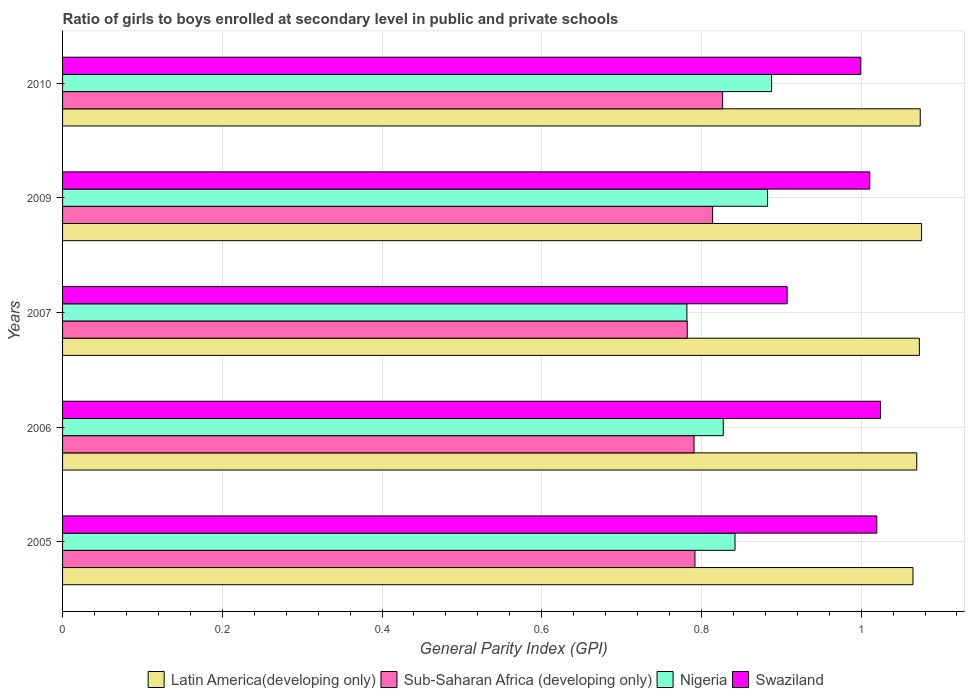How many different coloured bars are there?
Give a very brief answer. 4. How many groups of bars are there?
Offer a terse response. 5. Are the number of bars per tick equal to the number of legend labels?
Provide a short and direct response. Yes. Are the number of bars on each tick of the Y-axis equal?
Make the answer very short. Yes. How many bars are there on the 3rd tick from the bottom?
Provide a short and direct response. 4. What is the general parity index in Swaziland in 2006?
Your answer should be compact. 1.02. Across all years, what is the maximum general parity index in Latin America(developing only)?
Keep it short and to the point. 1.08. Across all years, what is the minimum general parity index in Nigeria?
Provide a succinct answer. 0.78. In which year was the general parity index in Latin America(developing only) minimum?
Ensure brevity in your answer.  2005. What is the total general parity index in Nigeria in the graph?
Offer a terse response. 4.22. What is the difference between the general parity index in Nigeria in 2009 and that in 2010?
Your answer should be very brief. -0. What is the difference between the general parity index in Sub-Saharan Africa (developing only) in 2010 and the general parity index in Latin America(developing only) in 2007?
Your answer should be compact. -0.25. What is the average general parity index in Latin America(developing only) per year?
Your answer should be very brief. 1.07. In the year 2009, what is the difference between the general parity index in Swaziland and general parity index in Latin America(developing only)?
Offer a very short reply. -0.06. In how many years, is the general parity index in Sub-Saharan Africa (developing only) greater than 1 ?
Offer a very short reply. 0. What is the ratio of the general parity index in Sub-Saharan Africa (developing only) in 2005 to that in 2007?
Ensure brevity in your answer.  1.01. Is the general parity index in Sub-Saharan Africa (developing only) in 2005 less than that in 2010?
Give a very brief answer. Yes. Is the difference between the general parity index in Swaziland in 2006 and 2007 greater than the difference between the general parity index in Latin America(developing only) in 2006 and 2007?
Provide a short and direct response. Yes. What is the difference between the highest and the second highest general parity index in Nigeria?
Your answer should be very brief. 0. What is the difference between the highest and the lowest general parity index in Nigeria?
Your answer should be compact. 0.11. Is the sum of the general parity index in Sub-Saharan Africa (developing only) in 2007 and 2009 greater than the maximum general parity index in Nigeria across all years?
Your answer should be compact. Yes. What does the 3rd bar from the top in 2007 represents?
Your response must be concise. Sub-Saharan Africa (developing only). What does the 3rd bar from the bottom in 2006 represents?
Your response must be concise. Nigeria. Is it the case that in every year, the sum of the general parity index in Latin America(developing only) and general parity index in Sub-Saharan Africa (developing only) is greater than the general parity index in Swaziland?
Offer a very short reply. Yes. How many bars are there?
Make the answer very short. 20. Are all the bars in the graph horizontal?
Provide a succinct answer. Yes. Where does the legend appear in the graph?
Offer a very short reply. Bottom center. How many legend labels are there?
Keep it short and to the point. 4. What is the title of the graph?
Provide a succinct answer. Ratio of girls to boys enrolled at secondary level in public and private schools. What is the label or title of the X-axis?
Provide a succinct answer. General Parity Index (GPI). What is the General Parity Index (GPI) in Latin America(developing only) in 2005?
Provide a short and direct response. 1.06. What is the General Parity Index (GPI) of Sub-Saharan Africa (developing only) in 2005?
Offer a very short reply. 0.79. What is the General Parity Index (GPI) of Nigeria in 2005?
Provide a succinct answer. 0.84. What is the General Parity Index (GPI) in Swaziland in 2005?
Your answer should be compact. 1.02. What is the General Parity Index (GPI) of Latin America(developing only) in 2006?
Offer a terse response. 1.07. What is the General Parity Index (GPI) of Sub-Saharan Africa (developing only) in 2006?
Keep it short and to the point. 0.79. What is the General Parity Index (GPI) in Nigeria in 2006?
Your answer should be compact. 0.83. What is the General Parity Index (GPI) in Swaziland in 2006?
Offer a terse response. 1.02. What is the General Parity Index (GPI) of Latin America(developing only) in 2007?
Your answer should be compact. 1.07. What is the General Parity Index (GPI) in Sub-Saharan Africa (developing only) in 2007?
Provide a succinct answer. 0.78. What is the General Parity Index (GPI) in Nigeria in 2007?
Your answer should be very brief. 0.78. What is the General Parity Index (GPI) of Swaziland in 2007?
Make the answer very short. 0.91. What is the General Parity Index (GPI) in Latin America(developing only) in 2009?
Make the answer very short. 1.08. What is the General Parity Index (GPI) in Sub-Saharan Africa (developing only) in 2009?
Your response must be concise. 0.81. What is the General Parity Index (GPI) of Nigeria in 2009?
Offer a very short reply. 0.88. What is the General Parity Index (GPI) in Swaziland in 2009?
Provide a succinct answer. 1.01. What is the General Parity Index (GPI) in Latin America(developing only) in 2010?
Your answer should be very brief. 1.07. What is the General Parity Index (GPI) in Sub-Saharan Africa (developing only) in 2010?
Provide a succinct answer. 0.83. What is the General Parity Index (GPI) in Nigeria in 2010?
Offer a terse response. 0.89. What is the General Parity Index (GPI) of Swaziland in 2010?
Give a very brief answer. 1. Across all years, what is the maximum General Parity Index (GPI) of Latin America(developing only)?
Provide a short and direct response. 1.08. Across all years, what is the maximum General Parity Index (GPI) of Sub-Saharan Africa (developing only)?
Ensure brevity in your answer.  0.83. Across all years, what is the maximum General Parity Index (GPI) of Nigeria?
Ensure brevity in your answer.  0.89. Across all years, what is the maximum General Parity Index (GPI) in Swaziland?
Give a very brief answer. 1.02. Across all years, what is the minimum General Parity Index (GPI) of Latin America(developing only)?
Your response must be concise. 1.06. Across all years, what is the minimum General Parity Index (GPI) in Sub-Saharan Africa (developing only)?
Ensure brevity in your answer.  0.78. Across all years, what is the minimum General Parity Index (GPI) in Nigeria?
Offer a terse response. 0.78. Across all years, what is the minimum General Parity Index (GPI) in Swaziland?
Keep it short and to the point. 0.91. What is the total General Parity Index (GPI) in Latin America(developing only) in the graph?
Provide a short and direct response. 5.36. What is the total General Parity Index (GPI) of Sub-Saharan Africa (developing only) in the graph?
Your response must be concise. 4.01. What is the total General Parity Index (GPI) of Nigeria in the graph?
Make the answer very short. 4.22. What is the total General Parity Index (GPI) in Swaziland in the graph?
Give a very brief answer. 4.96. What is the difference between the General Parity Index (GPI) of Latin America(developing only) in 2005 and that in 2006?
Keep it short and to the point. -0. What is the difference between the General Parity Index (GPI) in Sub-Saharan Africa (developing only) in 2005 and that in 2006?
Offer a terse response. 0. What is the difference between the General Parity Index (GPI) of Nigeria in 2005 and that in 2006?
Provide a short and direct response. 0.01. What is the difference between the General Parity Index (GPI) of Swaziland in 2005 and that in 2006?
Give a very brief answer. -0. What is the difference between the General Parity Index (GPI) of Latin America(developing only) in 2005 and that in 2007?
Give a very brief answer. -0.01. What is the difference between the General Parity Index (GPI) in Sub-Saharan Africa (developing only) in 2005 and that in 2007?
Provide a short and direct response. 0.01. What is the difference between the General Parity Index (GPI) of Nigeria in 2005 and that in 2007?
Offer a very short reply. 0.06. What is the difference between the General Parity Index (GPI) in Swaziland in 2005 and that in 2007?
Give a very brief answer. 0.11. What is the difference between the General Parity Index (GPI) of Latin America(developing only) in 2005 and that in 2009?
Your answer should be compact. -0.01. What is the difference between the General Parity Index (GPI) in Sub-Saharan Africa (developing only) in 2005 and that in 2009?
Your answer should be very brief. -0.02. What is the difference between the General Parity Index (GPI) of Nigeria in 2005 and that in 2009?
Provide a succinct answer. -0.04. What is the difference between the General Parity Index (GPI) in Swaziland in 2005 and that in 2009?
Ensure brevity in your answer.  0.01. What is the difference between the General Parity Index (GPI) of Latin America(developing only) in 2005 and that in 2010?
Your answer should be very brief. -0.01. What is the difference between the General Parity Index (GPI) in Sub-Saharan Africa (developing only) in 2005 and that in 2010?
Make the answer very short. -0.03. What is the difference between the General Parity Index (GPI) in Nigeria in 2005 and that in 2010?
Offer a terse response. -0.05. What is the difference between the General Parity Index (GPI) of Swaziland in 2005 and that in 2010?
Your answer should be compact. 0.02. What is the difference between the General Parity Index (GPI) in Latin America(developing only) in 2006 and that in 2007?
Provide a succinct answer. -0. What is the difference between the General Parity Index (GPI) of Sub-Saharan Africa (developing only) in 2006 and that in 2007?
Provide a short and direct response. 0.01. What is the difference between the General Parity Index (GPI) of Nigeria in 2006 and that in 2007?
Provide a short and direct response. 0.05. What is the difference between the General Parity Index (GPI) in Swaziland in 2006 and that in 2007?
Ensure brevity in your answer.  0.12. What is the difference between the General Parity Index (GPI) in Latin America(developing only) in 2006 and that in 2009?
Keep it short and to the point. -0.01. What is the difference between the General Parity Index (GPI) of Sub-Saharan Africa (developing only) in 2006 and that in 2009?
Your answer should be very brief. -0.02. What is the difference between the General Parity Index (GPI) in Nigeria in 2006 and that in 2009?
Your answer should be compact. -0.06. What is the difference between the General Parity Index (GPI) in Swaziland in 2006 and that in 2009?
Your answer should be very brief. 0.01. What is the difference between the General Parity Index (GPI) in Latin America(developing only) in 2006 and that in 2010?
Your answer should be very brief. -0. What is the difference between the General Parity Index (GPI) in Sub-Saharan Africa (developing only) in 2006 and that in 2010?
Offer a terse response. -0.04. What is the difference between the General Parity Index (GPI) in Nigeria in 2006 and that in 2010?
Offer a very short reply. -0.06. What is the difference between the General Parity Index (GPI) in Swaziland in 2006 and that in 2010?
Keep it short and to the point. 0.02. What is the difference between the General Parity Index (GPI) of Latin America(developing only) in 2007 and that in 2009?
Give a very brief answer. -0. What is the difference between the General Parity Index (GPI) in Sub-Saharan Africa (developing only) in 2007 and that in 2009?
Offer a terse response. -0.03. What is the difference between the General Parity Index (GPI) in Nigeria in 2007 and that in 2009?
Make the answer very short. -0.1. What is the difference between the General Parity Index (GPI) in Swaziland in 2007 and that in 2009?
Your answer should be very brief. -0.1. What is the difference between the General Parity Index (GPI) in Latin America(developing only) in 2007 and that in 2010?
Your answer should be compact. -0. What is the difference between the General Parity Index (GPI) of Sub-Saharan Africa (developing only) in 2007 and that in 2010?
Your response must be concise. -0.04. What is the difference between the General Parity Index (GPI) of Nigeria in 2007 and that in 2010?
Your answer should be very brief. -0.11. What is the difference between the General Parity Index (GPI) in Swaziland in 2007 and that in 2010?
Give a very brief answer. -0.09. What is the difference between the General Parity Index (GPI) of Latin America(developing only) in 2009 and that in 2010?
Keep it short and to the point. 0. What is the difference between the General Parity Index (GPI) of Sub-Saharan Africa (developing only) in 2009 and that in 2010?
Your answer should be compact. -0.01. What is the difference between the General Parity Index (GPI) in Nigeria in 2009 and that in 2010?
Make the answer very short. -0.01. What is the difference between the General Parity Index (GPI) of Swaziland in 2009 and that in 2010?
Provide a succinct answer. 0.01. What is the difference between the General Parity Index (GPI) in Latin America(developing only) in 2005 and the General Parity Index (GPI) in Sub-Saharan Africa (developing only) in 2006?
Keep it short and to the point. 0.27. What is the difference between the General Parity Index (GPI) in Latin America(developing only) in 2005 and the General Parity Index (GPI) in Nigeria in 2006?
Offer a terse response. 0.24. What is the difference between the General Parity Index (GPI) in Latin America(developing only) in 2005 and the General Parity Index (GPI) in Swaziland in 2006?
Offer a terse response. 0.04. What is the difference between the General Parity Index (GPI) of Sub-Saharan Africa (developing only) in 2005 and the General Parity Index (GPI) of Nigeria in 2006?
Your response must be concise. -0.04. What is the difference between the General Parity Index (GPI) of Sub-Saharan Africa (developing only) in 2005 and the General Parity Index (GPI) of Swaziland in 2006?
Provide a short and direct response. -0.23. What is the difference between the General Parity Index (GPI) in Nigeria in 2005 and the General Parity Index (GPI) in Swaziland in 2006?
Provide a succinct answer. -0.18. What is the difference between the General Parity Index (GPI) in Latin America(developing only) in 2005 and the General Parity Index (GPI) in Sub-Saharan Africa (developing only) in 2007?
Your answer should be compact. 0.28. What is the difference between the General Parity Index (GPI) of Latin America(developing only) in 2005 and the General Parity Index (GPI) of Nigeria in 2007?
Ensure brevity in your answer.  0.28. What is the difference between the General Parity Index (GPI) of Latin America(developing only) in 2005 and the General Parity Index (GPI) of Swaziland in 2007?
Your response must be concise. 0.16. What is the difference between the General Parity Index (GPI) in Sub-Saharan Africa (developing only) in 2005 and the General Parity Index (GPI) in Nigeria in 2007?
Give a very brief answer. 0.01. What is the difference between the General Parity Index (GPI) of Sub-Saharan Africa (developing only) in 2005 and the General Parity Index (GPI) of Swaziland in 2007?
Give a very brief answer. -0.12. What is the difference between the General Parity Index (GPI) of Nigeria in 2005 and the General Parity Index (GPI) of Swaziland in 2007?
Provide a short and direct response. -0.07. What is the difference between the General Parity Index (GPI) of Latin America(developing only) in 2005 and the General Parity Index (GPI) of Sub-Saharan Africa (developing only) in 2009?
Offer a terse response. 0.25. What is the difference between the General Parity Index (GPI) in Latin America(developing only) in 2005 and the General Parity Index (GPI) in Nigeria in 2009?
Make the answer very short. 0.18. What is the difference between the General Parity Index (GPI) in Latin America(developing only) in 2005 and the General Parity Index (GPI) in Swaziland in 2009?
Your response must be concise. 0.05. What is the difference between the General Parity Index (GPI) of Sub-Saharan Africa (developing only) in 2005 and the General Parity Index (GPI) of Nigeria in 2009?
Provide a short and direct response. -0.09. What is the difference between the General Parity Index (GPI) of Sub-Saharan Africa (developing only) in 2005 and the General Parity Index (GPI) of Swaziland in 2009?
Make the answer very short. -0.22. What is the difference between the General Parity Index (GPI) of Nigeria in 2005 and the General Parity Index (GPI) of Swaziland in 2009?
Make the answer very short. -0.17. What is the difference between the General Parity Index (GPI) in Latin America(developing only) in 2005 and the General Parity Index (GPI) in Sub-Saharan Africa (developing only) in 2010?
Offer a terse response. 0.24. What is the difference between the General Parity Index (GPI) in Latin America(developing only) in 2005 and the General Parity Index (GPI) in Nigeria in 2010?
Offer a terse response. 0.18. What is the difference between the General Parity Index (GPI) in Latin America(developing only) in 2005 and the General Parity Index (GPI) in Swaziland in 2010?
Give a very brief answer. 0.07. What is the difference between the General Parity Index (GPI) of Sub-Saharan Africa (developing only) in 2005 and the General Parity Index (GPI) of Nigeria in 2010?
Provide a short and direct response. -0.1. What is the difference between the General Parity Index (GPI) in Sub-Saharan Africa (developing only) in 2005 and the General Parity Index (GPI) in Swaziland in 2010?
Offer a very short reply. -0.21. What is the difference between the General Parity Index (GPI) of Nigeria in 2005 and the General Parity Index (GPI) of Swaziland in 2010?
Offer a terse response. -0.16. What is the difference between the General Parity Index (GPI) of Latin America(developing only) in 2006 and the General Parity Index (GPI) of Sub-Saharan Africa (developing only) in 2007?
Make the answer very short. 0.29. What is the difference between the General Parity Index (GPI) of Latin America(developing only) in 2006 and the General Parity Index (GPI) of Nigeria in 2007?
Your answer should be compact. 0.29. What is the difference between the General Parity Index (GPI) in Latin America(developing only) in 2006 and the General Parity Index (GPI) in Swaziland in 2007?
Give a very brief answer. 0.16. What is the difference between the General Parity Index (GPI) of Sub-Saharan Africa (developing only) in 2006 and the General Parity Index (GPI) of Nigeria in 2007?
Your answer should be very brief. 0.01. What is the difference between the General Parity Index (GPI) in Sub-Saharan Africa (developing only) in 2006 and the General Parity Index (GPI) in Swaziland in 2007?
Make the answer very short. -0.12. What is the difference between the General Parity Index (GPI) of Nigeria in 2006 and the General Parity Index (GPI) of Swaziland in 2007?
Provide a short and direct response. -0.08. What is the difference between the General Parity Index (GPI) in Latin America(developing only) in 2006 and the General Parity Index (GPI) in Sub-Saharan Africa (developing only) in 2009?
Give a very brief answer. 0.26. What is the difference between the General Parity Index (GPI) in Latin America(developing only) in 2006 and the General Parity Index (GPI) in Nigeria in 2009?
Offer a terse response. 0.19. What is the difference between the General Parity Index (GPI) in Latin America(developing only) in 2006 and the General Parity Index (GPI) in Swaziland in 2009?
Offer a terse response. 0.06. What is the difference between the General Parity Index (GPI) in Sub-Saharan Africa (developing only) in 2006 and the General Parity Index (GPI) in Nigeria in 2009?
Ensure brevity in your answer.  -0.09. What is the difference between the General Parity Index (GPI) of Sub-Saharan Africa (developing only) in 2006 and the General Parity Index (GPI) of Swaziland in 2009?
Offer a very short reply. -0.22. What is the difference between the General Parity Index (GPI) of Nigeria in 2006 and the General Parity Index (GPI) of Swaziland in 2009?
Provide a short and direct response. -0.18. What is the difference between the General Parity Index (GPI) of Latin America(developing only) in 2006 and the General Parity Index (GPI) of Sub-Saharan Africa (developing only) in 2010?
Your response must be concise. 0.24. What is the difference between the General Parity Index (GPI) in Latin America(developing only) in 2006 and the General Parity Index (GPI) in Nigeria in 2010?
Your answer should be very brief. 0.18. What is the difference between the General Parity Index (GPI) of Latin America(developing only) in 2006 and the General Parity Index (GPI) of Swaziland in 2010?
Your response must be concise. 0.07. What is the difference between the General Parity Index (GPI) of Sub-Saharan Africa (developing only) in 2006 and the General Parity Index (GPI) of Nigeria in 2010?
Provide a short and direct response. -0.1. What is the difference between the General Parity Index (GPI) in Sub-Saharan Africa (developing only) in 2006 and the General Parity Index (GPI) in Swaziland in 2010?
Your answer should be compact. -0.21. What is the difference between the General Parity Index (GPI) in Nigeria in 2006 and the General Parity Index (GPI) in Swaziland in 2010?
Offer a terse response. -0.17. What is the difference between the General Parity Index (GPI) in Latin America(developing only) in 2007 and the General Parity Index (GPI) in Sub-Saharan Africa (developing only) in 2009?
Ensure brevity in your answer.  0.26. What is the difference between the General Parity Index (GPI) in Latin America(developing only) in 2007 and the General Parity Index (GPI) in Nigeria in 2009?
Your answer should be compact. 0.19. What is the difference between the General Parity Index (GPI) in Latin America(developing only) in 2007 and the General Parity Index (GPI) in Swaziland in 2009?
Give a very brief answer. 0.06. What is the difference between the General Parity Index (GPI) in Sub-Saharan Africa (developing only) in 2007 and the General Parity Index (GPI) in Nigeria in 2009?
Offer a very short reply. -0.1. What is the difference between the General Parity Index (GPI) of Sub-Saharan Africa (developing only) in 2007 and the General Parity Index (GPI) of Swaziland in 2009?
Make the answer very short. -0.23. What is the difference between the General Parity Index (GPI) in Nigeria in 2007 and the General Parity Index (GPI) in Swaziland in 2009?
Keep it short and to the point. -0.23. What is the difference between the General Parity Index (GPI) of Latin America(developing only) in 2007 and the General Parity Index (GPI) of Sub-Saharan Africa (developing only) in 2010?
Make the answer very short. 0.25. What is the difference between the General Parity Index (GPI) in Latin America(developing only) in 2007 and the General Parity Index (GPI) in Nigeria in 2010?
Offer a very short reply. 0.19. What is the difference between the General Parity Index (GPI) of Latin America(developing only) in 2007 and the General Parity Index (GPI) of Swaziland in 2010?
Ensure brevity in your answer.  0.07. What is the difference between the General Parity Index (GPI) in Sub-Saharan Africa (developing only) in 2007 and the General Parity Index (GPI) in Nigeria in 2010?
Keep it short and to the point. -0.11. What is the difference between the General Parity Index (GPI) of Sub-Saharan Africa (developing only) in 2007 and the General Parity Index (GPI) of Swaziland in 2010?
Your answer should be compact. -0.22. What is the difference between the General Parity Index (GPI) in Nigeria in 2007 and the General Parity Index (GPI) in Swaziland in 2010?
Provide a short and direct response. -0.22. What is the difference between the General Parity Index (GPI) of Latin America(developing only) in 2009 and the General Parity Index (GPI) of Sub-Saharan Africa (developing only) in 2010?
Give a very brief answer. 0.25. What is the difference between the General Parity Index (GPI) of Latin America(developing only) in 2009 and the General Parity Index (GPI) of Nigeria in 2010?
Your response must be concise. 0.19. What is the difference between the General Parity Index (GPI) of Latin America(developing only) in 2009 and the General Parity Index (GPI) of Swaziland in 2010?
Give a very brief answer. 0.08. What is the difference between the General Parity Index (GPI) of Sub-Saharan Africa (developing only) in 2009 and the General Parity Index (GPI) of Nigeria in 2010?
Offer a very short reply. -0.07. What is the difference between the General Parity Index (GPI) of Sub-Saharan Africa (developing only) in 2009 and the General Parity Index (GPI) of Swaziland in 2010?
Ensure brevity in your answer.  -0.19. What is the difference between the General Parity Index (GPI) in Nigeria in 2009 and the General Parity Index (GPI) in Swaziland in 2010?
Ensure brevity in your answer.  -0.12. What is the average General Parity Index (GPI) in Latin America(developing only) per year?
Ensure brevity in your answer.  1.07. What is the average General Parity Index (GPI) in Sub-Saharan Africa (developing only) per year?
Give a very brief answer. 0.8. What is the average General Parity Index (GPI) of Nigeria per year?
Keep it short and to the point. 0.84. What is the average General Parity Index (GPI) of Swaziland per year?
Ensure brevity in your answer.  0.99. In the year 2005, what is the difference between the General Parity Index (GPI) of Latin America(developing only) and General Parity Index (GPI) of Sub-Saharan Africa (developing only)?
Your response must be concise. 0.27. In the year 2005, what is the difference between the General Parity Index (GPI) of Latin America(developing only) and General Parity Index (GPI) of Nigeria?
Provide a succinct answer. 0.22. In the year 2005, what is the difference between the General Parity Index (GPI) in Latin America(developing only) and General Parity Index (GPI) in Swaziland?
Ensure brevity in your answer.  0.05. In the year 2005, what is the difference between the General Parity Index (GPI) in Sub-Saharan Africa (developing only) and General Parity Index (GPI) in Nigeria?
Ensure brevity in your answer.  -0.05. In the year 2005, what is the difference between the General Parity Index (GPI) of Sub-Saharan Africa (developing only) and General Parity Index (GPI) of Swaziland?
Keep it short and to the point. -0.23. In the year 2005, what is the difference between the General Parity Index (GPI) in Nigeria and General Parity Index (GPI) in Swaziland?
Provide a short and direct response. -0.18. In the year 2006, what is the difference between the General Parity Index (GPI) of Latin America(developing only) and General Parity Index (GPI) of Sub-Saharan Africa (developing only)?
Offer a very short reply. 0.28. In the year 2006, what is the difference between the General Parity Index (GPI) of Latin America(developing only) and General Parity Index (GPI) of Nigeria?
Provide a short and direct response. 0.24. In the year 2006, what is the difference between the General Parity Index (GPI) in Latin America(developing only) and General Parity Index (GPI) in Swaziland?
Keep it short and to the point. 0.05. In the year 2006, what is the difference between the General Parity Index (GPI) of Sub-Saharan Africa (developing only) and General Parity Index (GPI) of Nigeria?
Offer a very short reply. -0.04. In the year 2006, what is the difference between the General Parity Index (GPI) in Sub-Saharan Africa (developing only) and General Parity Index (GPI) in Swaziland?
Offer a very short reply. -0.23. In the year 2006, what is the difference between the General Parity Index (GPI) in Nigeria and General Parity Index (GPI) in Swaziland?
Give a very brief answer. -0.2. In the year 2007, what is the difference between the General Parity Index (GPI) of Latin America(developing only) and General Parity Index (GPI) of Sub-Saharan Africa (developing only)?
Provide a short and direct response. 0.29. In the year 2007, what is the difference between the General Parity Index (GPI) in Latin America(developing only) and General Parity Index (GPI) in Nigeria?
Offer a terse response. 0.29. In the year 2007, what is the difference between the General Parity Index (GPI) of Latin America(developing only) and General Parity Index (GPI) of Swaziland?
Give a very brief answer. 0.17. In the year 2007, what is the difference between the General Parity Index (GPI) of Sub-Saharan Africa (developing only) and General Parity Index (GPI) of Nigeria?
Your response must be concise. 0. In the year 2007, what is the difference between the General Parity Index (GPI) in Sub-Saharan Africa (developing only) and General Parity Index (GPI) in Swaziland?
Your answer should be very brief. -0.13. In the year 2007, what is the difference between the General Parity Index (GPI) of Nigeria and General Parity Index (GPI) of Swaziland?
Ensure brevity in your answer.  -0.13. In the year 2009, what is the difference between the General Parity Index (GPI) of Latin America(developing only) and General Parity Index (GPI) of Sub-Saharan Africa (developing only)?
Ensure brevity in your answer.  0.26. In the year 2009, what is the difference between the General Parity Index (GPI) in Latin America(developing only) and General Parity Index (GPI) in Nigeria?
Your answer should be compact. 0.19. In the year 2009, what is the difference between the General Parity Index (GPI) in Latin America(developing only) and General Parity Index (GPI) in Swaziland?
Make the answer very short. 0.06. In the year 2009, what is the difference between the General Parity Index (GPI) of Sub-Saharan Africa (developing only) and General Parity Index (GPI) of Nigeria?
Provide a succinct answer. -0.07. In the year 2009, what is the difference between the General Parity Index (GPI) in Sub-Saharan Africa (developing only) and General Parity Index (GPI) in Swaziland?
Your answer should be very brief. -0.2. In the year 2009, what is the difference between the General Parity Index (GPI) of Nigeria and General Parity Index (GPI) of Swaziland?
Make the answer very short. -0.13. In the year 2010, what is the difference between the General Parity Index (GPI) of Latin America(developing only) and General Parity Index (GPI) of Sub-Saharan Africa (developing only)?
Provide a succinct answer. 0.25. In the year 2010, what is the difference between the General Parity Index (GPI) of Latin America(developing only) and General Parity Index (GPI) of Nigeria?
Your answer should be very brief. 0.19. In the year 2010, what is the difference between the General Parity Index (GPI) of Latin America(developing only) and General Parity Index (GPI) of Swaziland?
Offer a very short reply. 0.07. In the year 2010, what is the difference between the General Parity Index (GPI) of Sub-Saharan Africa (developing only) and General Parity Index (GPI) of Nigeria?
Offer a very short reply. -0.06. In the year 2010, what is the difference between the General Parity Index (GPI) in Sub-Saharan Africa (developing only) and General Parity Index (GPI) in Swaziland?
Your answer should be compact. -0.17. In the year 2010, what is the difference between the General Parity Index (GPI) in Nigeria and General Parity Index (GPI) in Swaziland?
Offer a terse response. -0.11. What is the ratio of the General Parity Index (GPI) of Sub-Saharan Africa (developing only) in 2005 to that in 2006?
Offer a terse response. 1. What is the ratio of the General Parity Index (GPI) in Nigeria in 2005 to that in 2006?
Your response must be concise. 1.02. What is the ratio of the General Parity Index (GPI) of Sub-Saharan Africa (developing only) in 2005 to that in 2007?
Your answer should be very brief. 1.01. What is the ratio of the General Parity Index (GPI) of Nigeria in 2005 to that in 2007?
Offer a very short reply. 1.08. What is the ratio of the General Parity Index (GPI) of Swaziland in 2005 to that in 2007?
Provide a short and direct response. 1.12. What is the ratio of the General Parity Index (GPI) in Sub-Saharan Africa (developing only) in 2005 to that in 2009?
Provide a short and direct response. 0.97. What is the ratio of the General Parity Index (GPI) of Nigeria in 2005 to that in 2009?
Provide a short and direct response. 0.95. What is the ratio of the General Parity Index (GPI) of Swaziland in 2005 to that in 2009?
Provide a succinct answer. 1.01. What is the ratio of the General Parity Index (GPI) in Latin America(developing only) in 2005 to that in 2010?
Your answer should be compact. 0.99. What is the ratio of the General Parity Index (GPI) in Sub-Saharan Africa (developing only) in 2005 to that in 2010?
Your answer should be very brief. 0.96. What is the ratio of the General Parity Index (GPI) in Nigeria in 2005 to that in 2010?
Provide a short and direct response. 0.95. What is the ratio of the General Parity Index (GPI) in Swaziland in 2005 to that in 2010?
Keep it short and to the point. 1.02. What is the ratio of the General Parity Index (GPI) of Latin America(developing only) in 2006 to that in 2007?
Offer a very short reply. 1. What is the ratio of the General Parity Index (GPI) of Sub-Saharan Africa (developing only) in 2006 to that in 2007?
Provide a succinct answer. 1.01. What is the ratio of the General Parity Index (GPI) in Nigeria in 2006 to that in 2007?
Ensure brevity in your answer.  1.06. What is the ratio of the General Parity Index (GPI) of Swaziland in 2006 to that in 2007?
Provide a short and direct response. 1.13. What is the ratio of the General Parity Index (GPI) of Sub-Saharan Africa (developing only) in 2006 to that in 2009?
Give a very brief answer. 0.97. What is the ratio of the General Parity Index (GPI) of Nigeria in 2006 to that in 2009?
Offer a terse response. 0.94. What is the ratio of the General Parity Index (GPI) of Swaziland in 2006 to that in 2009?
Provide a short and direct response. 1.01. What is the ratio of the General Parity Index (GPI) of Sub-Saharan Africa (developing only) in 2006 to that in 2010?
Make the answer very short. 0.96. What is the ratio of the General Parity Index (GPI) in Nigeria in 2006 to that in 2010?
Keep it short and to the point. 0.93. What is the ratio of the General Parity Index (GPI) in Swaziland in 2006 to that in 2010?
Offer a very short reply. 1.02. What is the ratio of the General Parity Index (GPI) in Latin America(developing only) in 2007 to that in 2009?
Ensure brevity in your answer.  1. What is the ratio of the General Parity Index (GPI) in Sub-Saharan Africa (developing only) in 2007 to that in 2009?
Give a very brief answer. 0.96. What is the ratio of the General Parity Index (GPI) in Nigeria in 2007 to that in 2009?
Your response must be concise. 0.89. What is the ratio of the General Parity Index (GPI) of Swaziland in 2007 to that in 2009?
Provide a short and direct response. 0.9. What is the ratio of the General Parity Index (GPI) in Latin America(developing only) in 2007 to that in 2010?
Provide a succinct answer. 1. What is the ratio of the General Parity Index (GPI) in Sub-Saharan Africa (developing only) in 2007 to that in 2010?
Give a very brief answer. 0.95. What is the ratio of the General Parity Index (GPI) in Nigeria in 2007 to that in 2010?
Provide a short and direct response. 0.88. What is the ratio of the General Parity Index (GPI) of Swaziland in 2007 to that in 2010?
Provide a short and direct response. 0.91. What is the ratio of the General Parity Index (GPI) in Latin America(developing only) in 2009 to that in 2010?
Make the answer very short. 1. What is the ratio of the General Parity Index (GPI) of Swaziland in 2009 to that in 2010?
Offer a very short reply. 1.01. What is the difference between the highest and the second highest General Parity Index (GPI) in Latin America(developing only)?
Keep it short and to the point. 0. What is the difference between the highest and the second highest General Parity Index (GPI) in Sub-Saharan Africa (developing only)?
Make the answer very short. 0.01. What is the difference between the highest and the second highest General Parity Index (GPI) of Nigeria?
Make the answer very short. 0.01. What is the difference between the highest and the second highest General Parity Index (GPI) in Swaziland?
Provide a succinct answer. 0. What is the difference between the highest and the lowest General Parity Index (GPI) in Latin America(developing only)?
Make the answer very short. 0.01. What is the difference between the highest and the lowest General Parity Index (GPI) of Sub-Saharan Africa (developing only)?
Your answer should be very brief. 0.04. What is the difference between the highest and the lowest General Parity Index (GPI) in Nigeria?
Your answer should be compact. 0.11. What is the difference between the highest and the lowest General Parity Index (GPI) of Swaziland?
Provide a short and direct response. 0.12. 